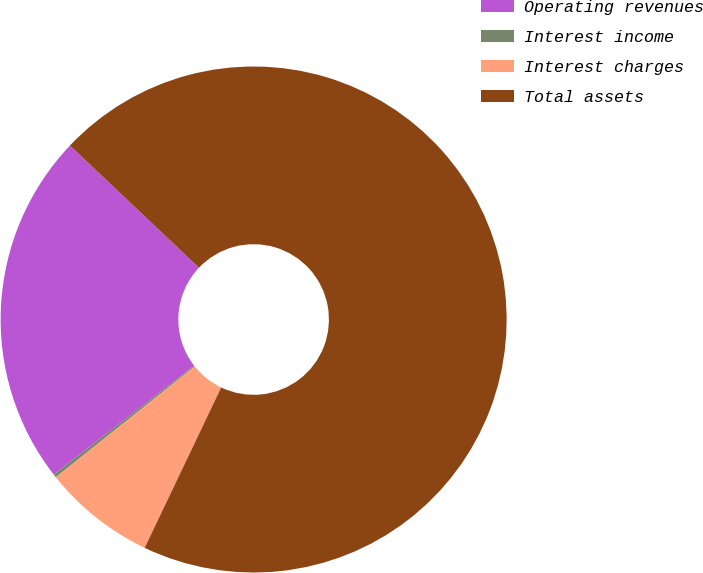Convert chart to OTSL. <chart><loc_0><loc_0><loc_500><loc_500><pie_chart><fcel>Operating revenues<fcel>Interest income<fcel>Interest charges<fcel>Total assets<nl><fcel>22.57%<fcel>0.21%<fcel>7.2%<fcel>70.02%<nl></chart> 